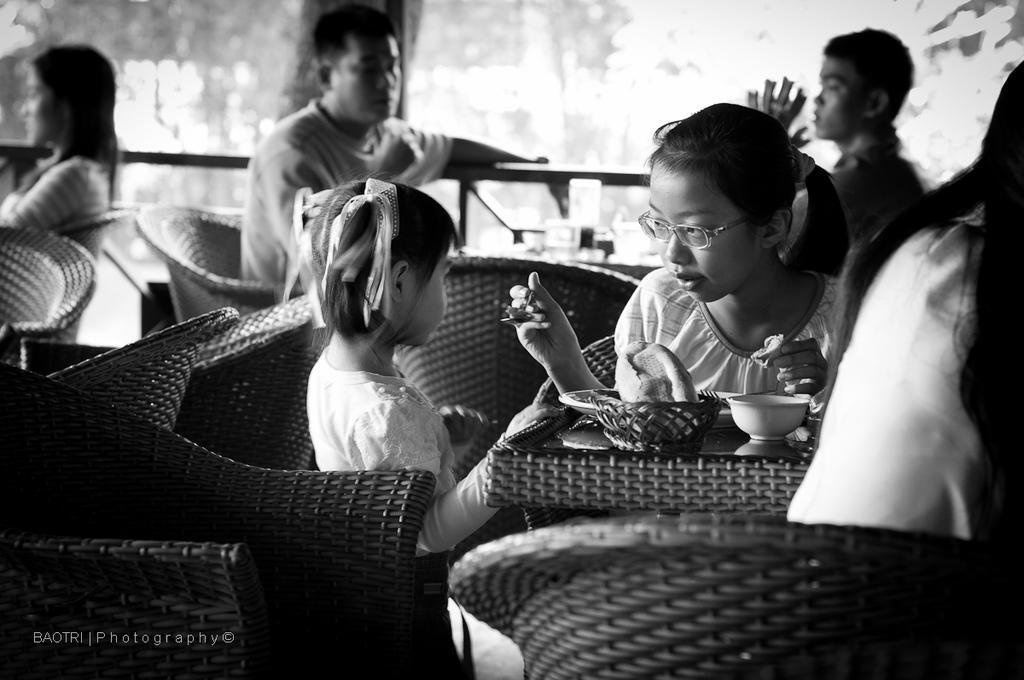How would you summarize this image in a sentence or two? In this image there are group of person sitting on a chair. In the center girl is holding a spoon and is feeding to the younger girl sitting on the left side. In the background there are three persons sitting on a chair. At the right side the person is sitting on a chair wearing a white colour dress. On this table there is a bowl, basket and a plate. 